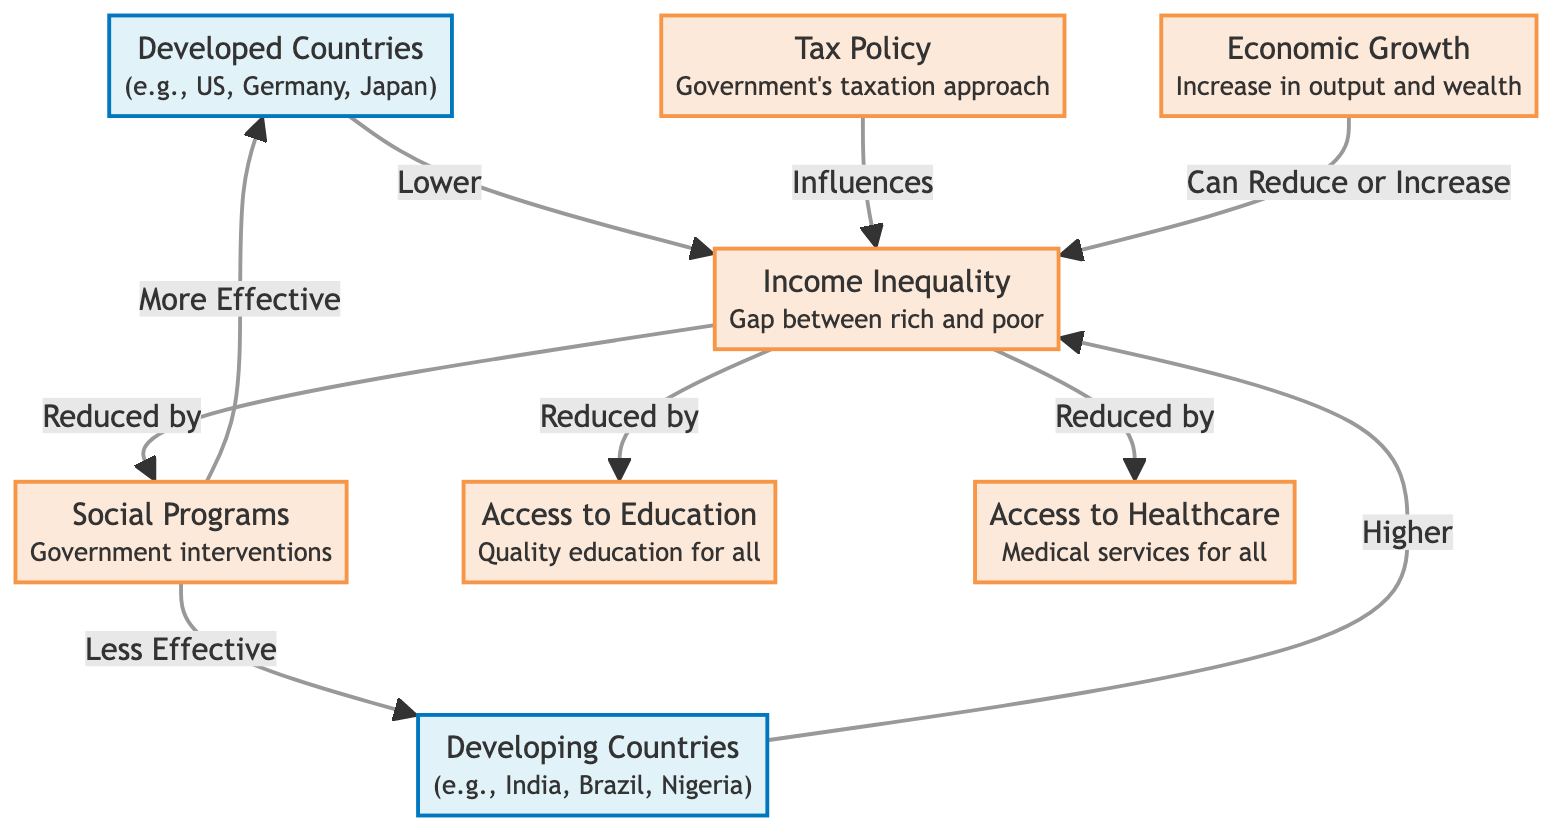What is the relationship between developed countries and income inequality? The diagram indicates that developed countries are associated with lower income inequality, as evidenced by the line connecting "developed countries" to "income inequality" with the label "Lower."
Answer: Lower How many factors are shown that can reduce income inequality? The diagram lists three distinct factors that can reduce income inequality: social programs, education access, and healthcare access. Counting these factors provides the answer.
Answer: Three Which type of countries has higher income inequality? According to the diagram, developing countries are linked to higher income inequality, as indicated by the label "Higher" connected to "income inequality."
Answer: Developing Countries What effect does economic growth have on income inequality? The diagram states that economic growth can either reduce or increase income inequality, as shown by the label on the arrow connecting "economic growth" to "income inequality."
Answer: Can Reduce or Increase How are social programs more effective in reducing income inequality in developed countries than in developing countries? The diagram shows two arrows from "social programs" to "income inequality," indicating it is "More Effective" in developed countries and "Less Effective" in developing countries, highlighting the comparative effectiveness.
Answer: More Effective What type of policies influence income inequality according to the diagram? The diagram specifically links "tax policy" to "income inequality" with the label "Influences", indicating that tax policies are a factor that affects income inequality.
Answer: Tax Policy Which two access points are noted as reducing income inequality in the diagram? The diagram shows two points: "access to education" and "access to healthcare," both linked to "income inequality" with arrows labeled "Reduced by."
Answer: Access to Education and Access to Healthcare What is the main factor that differentiates income inequality levels between developed and developing countries? The key distinction highlighted in the diagram is found within the "income inequality" node, where developed countries show a connection to "Lower" levels and developing countries show a connection to "Higher" levels, reinforcing the significant disparity.
Answer: Social Programs 